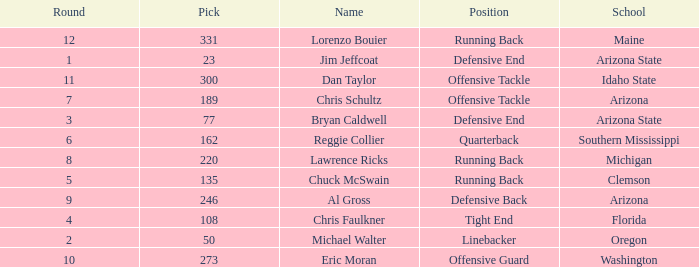What is the number of the pick for round 11? 300.0. 